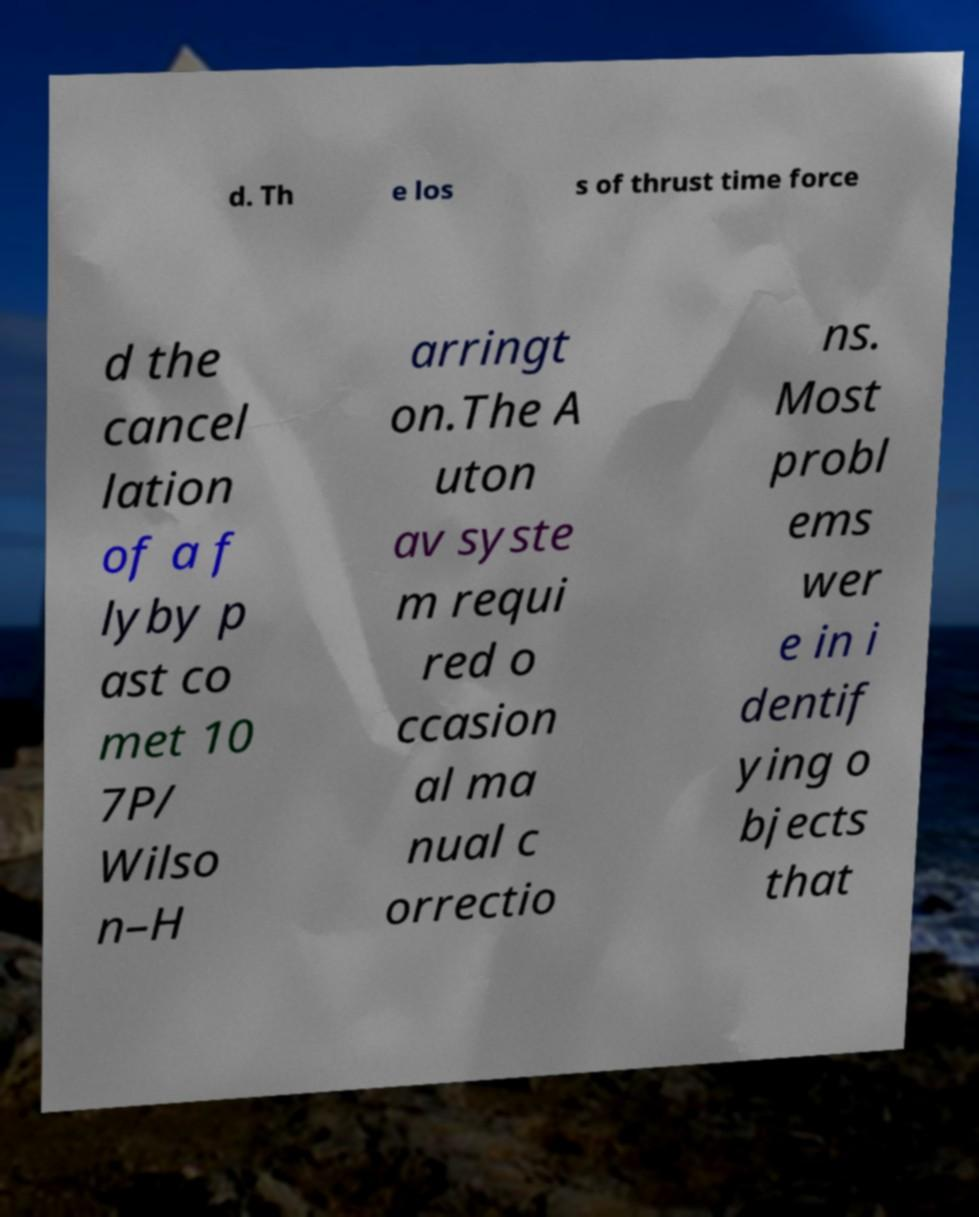Could you assist in decoding the text presented in this image and type it out clearly? d. Th e los s of thrust time force d the cancel lation of a f lyby p ast co met 10 7P/ Wilso n–H arringt on.The A uton av syste m requi red o ccasion al ma nual c orrectio ns. Most probl ems wer e in i dentif ying o bjects that 